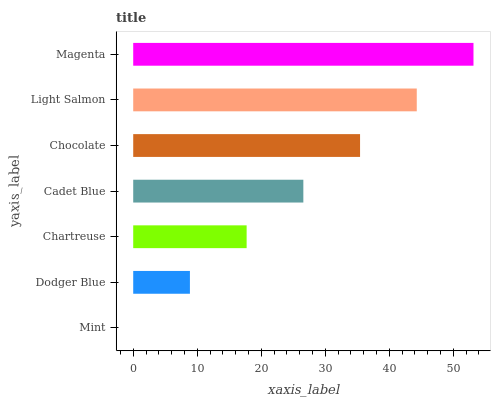Is Mint the minimum?
Answer yes or no. Yes. Is Magenta the maximum?
Answer yes or no. Yes. Is Dodger Blue the minimum?
Answer yes or no. No. Is Dodger Blue the maximum?
Answer yes or no. No. Is Dodger Blue greater than Mint?
Answer yes or no. Yes. Is Mint less than Dodger Blue?
Answer yes or no. Yes. Is Mint greater than Dodger Blue?
Answer yes or no. No. Is Dodger Blue less than Mint?
Answer yes or no. No. Is Cadet Blue the high median?
Answer yes or no. Yes. Is Cadet Blue the low median?
Answer yes or no. Yes. Is Light Salmon the high median?
Answer yes or no. No. Is Mint the low median?
Answer yes or no. No. 